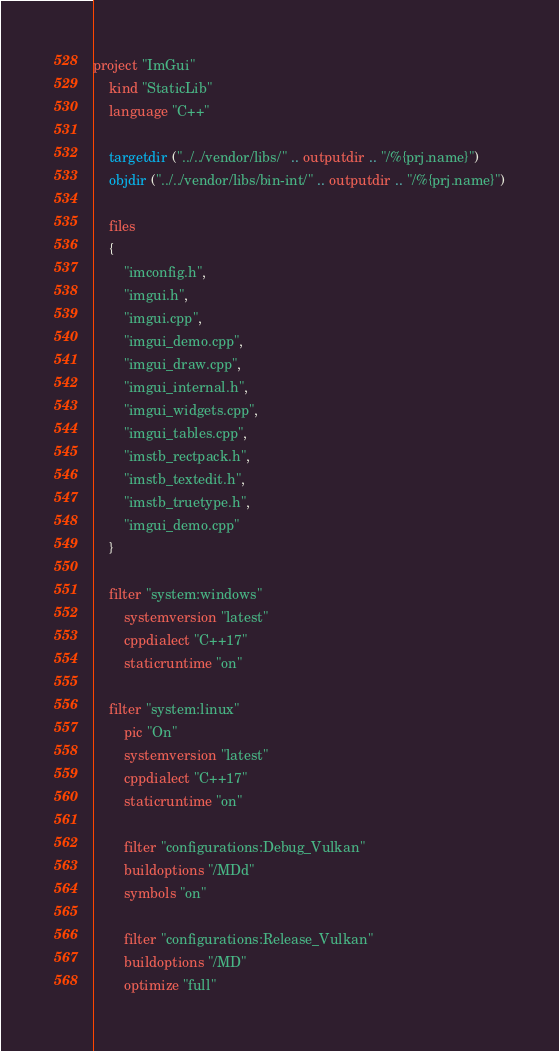Convert code to text. <code><loc_0><loc_0><loc_500><loc_500><_Lua_>project "ImGui"
	kind "StaticLib"
	language "C++"

	targetdir ("../../vendor/libs/" .. outputdir .. "/%{prj.name}")
	objdir ("../../vendor/libs/bin-int/" .. outputdir .. "/%{prj.name}")

	files
	{
		"imconfig.h",
		"imgui.h",
		"imgui.cpp",
        "imgui_demo.cpp",
		"imgui_draw.cpp",
		"imgui_internal.h",
		"imgui_widgets.cpp",
        "imgui_tables.cpp",
		"imstb_rectpack.h",
		"imstb_textedit.h",
		"imstb_truetype.h",
		"imgui_demo.cpp"
	}

	filter "system:windows"
		systemversion "latest"
		cppdialect "C++17"
		staticruntime "on"

	filter "system:linux"
		pic "On"
		systemversion "latest"
		cppdialect "C++17"
		staticruntime "on"

		filter "configurations:Debug_Vulkan"
		buildoptions "/MDd"
		symbols "on"
		
		filter "configurations:Release_Vulkan"
		buildoptions "/MD"
		optimize "full"
</code> 